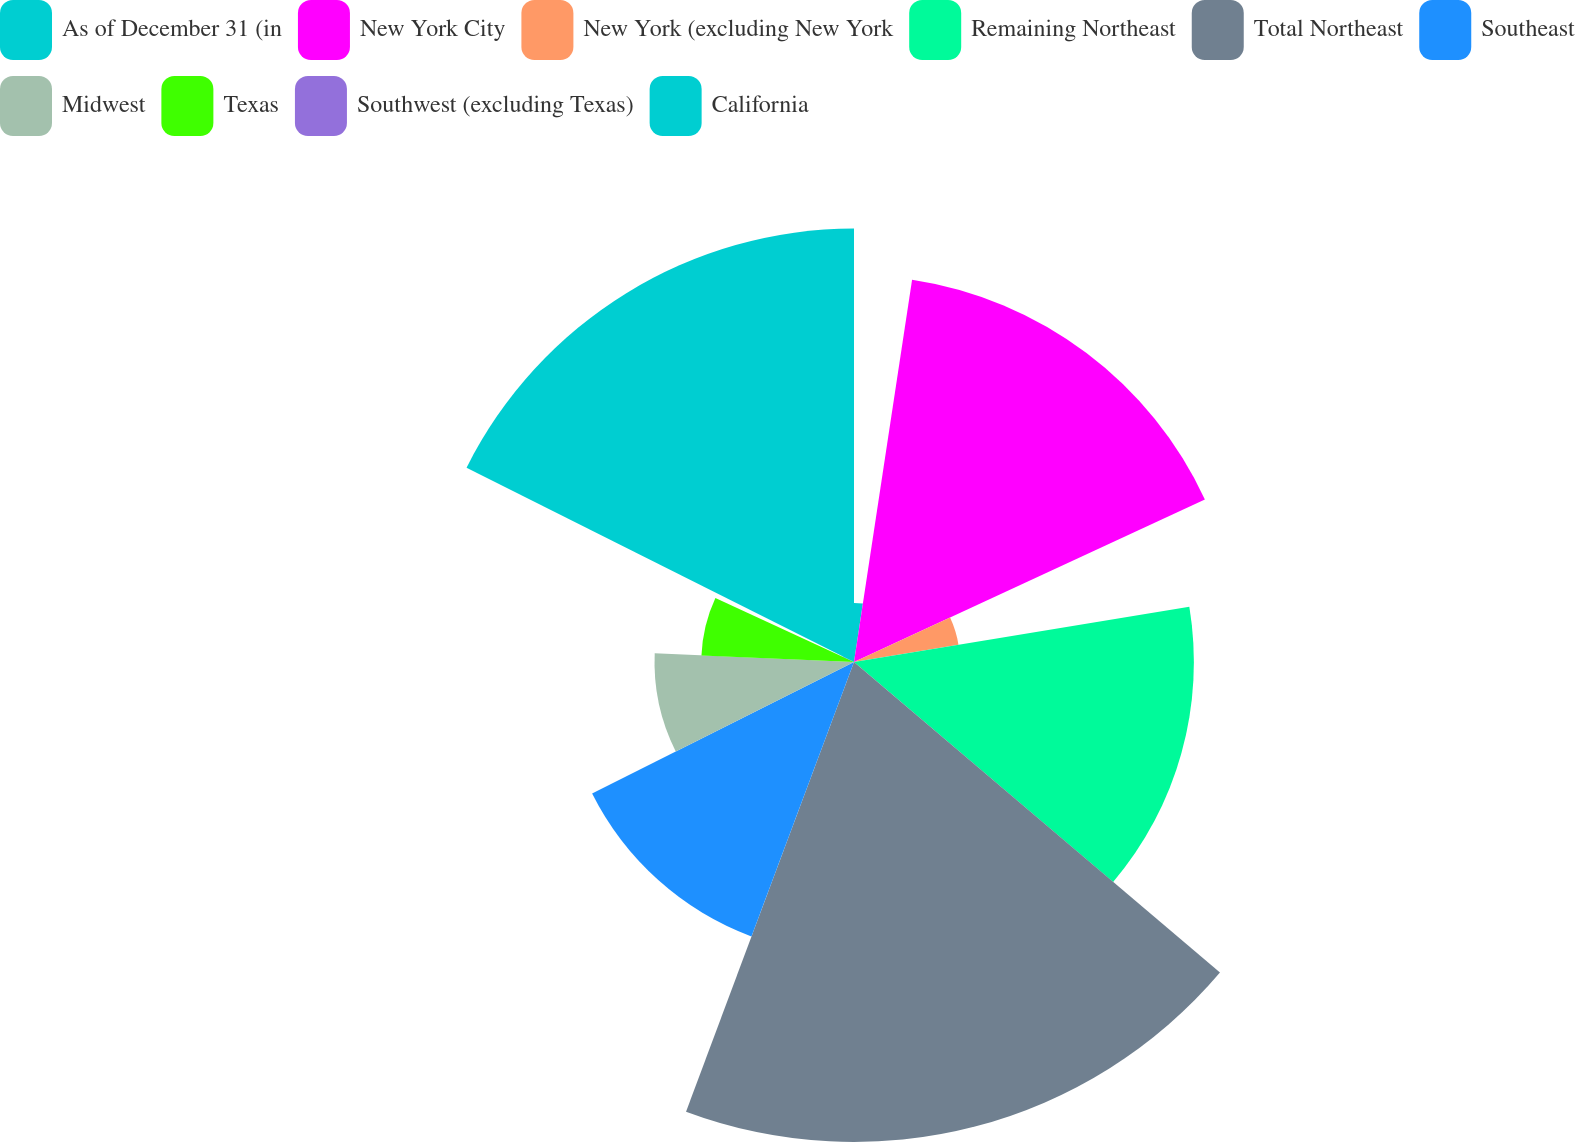<chart> <loc_0><loc_0><loc_500><loc_500><pie_chart><fcel>As of December 31 (in<fcel>New York City<fcel>New York (excluding New York<fcel>Remaining Northeast<fcel>Total Northeast<fcel>Southeast<fcel>Midwest<fcel>Texas<fcel>Southwest (excluding Texas)<fcel>California<nl><fcel>2.4%<fcel>15.7%<fcel>4.3%<fcel>13.8%<fcel>19.49%<fcel>11.9%<fcel>8.1%<fcel>6.2%<fcel>0.51%<fcel>17.6%<nl></chart> 